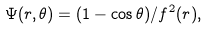Convert formula to latex. <formula><loc_0><loc_0><loc_500><loc_500>\Psi ( r , \theta ) = ( 1 - \cos \theta ) / f ^ { 2 } ( r ) ,</formula> 